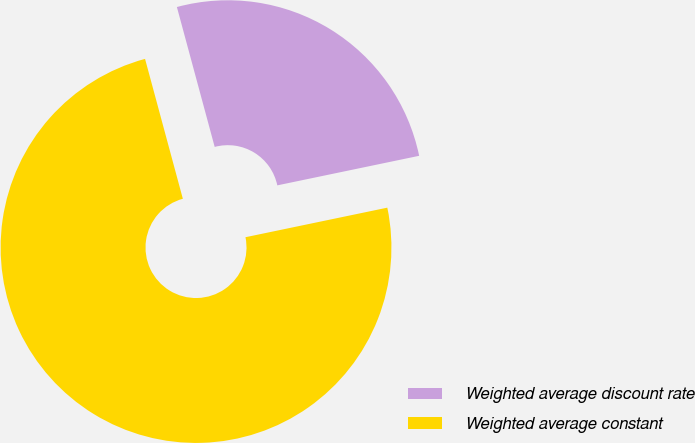Convert chart. <chart><loc_0><loc_0><loc_500><loc_500><pie_chart><fcel>Weighted average discount rate<fcel>Weighted average constant<nl><fcel>25.93%<fcel>74.07%<nl></chart> 